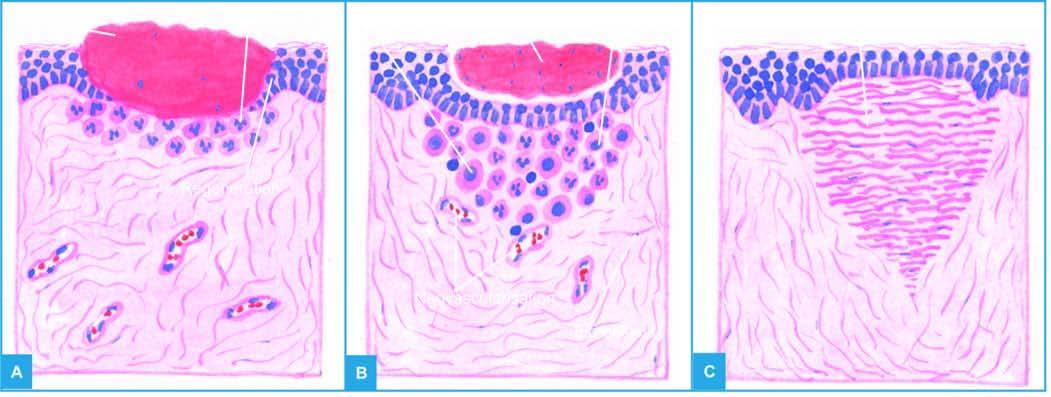what is the open wound filled with?
Answer the question using a single word or phrase. Blood clot 